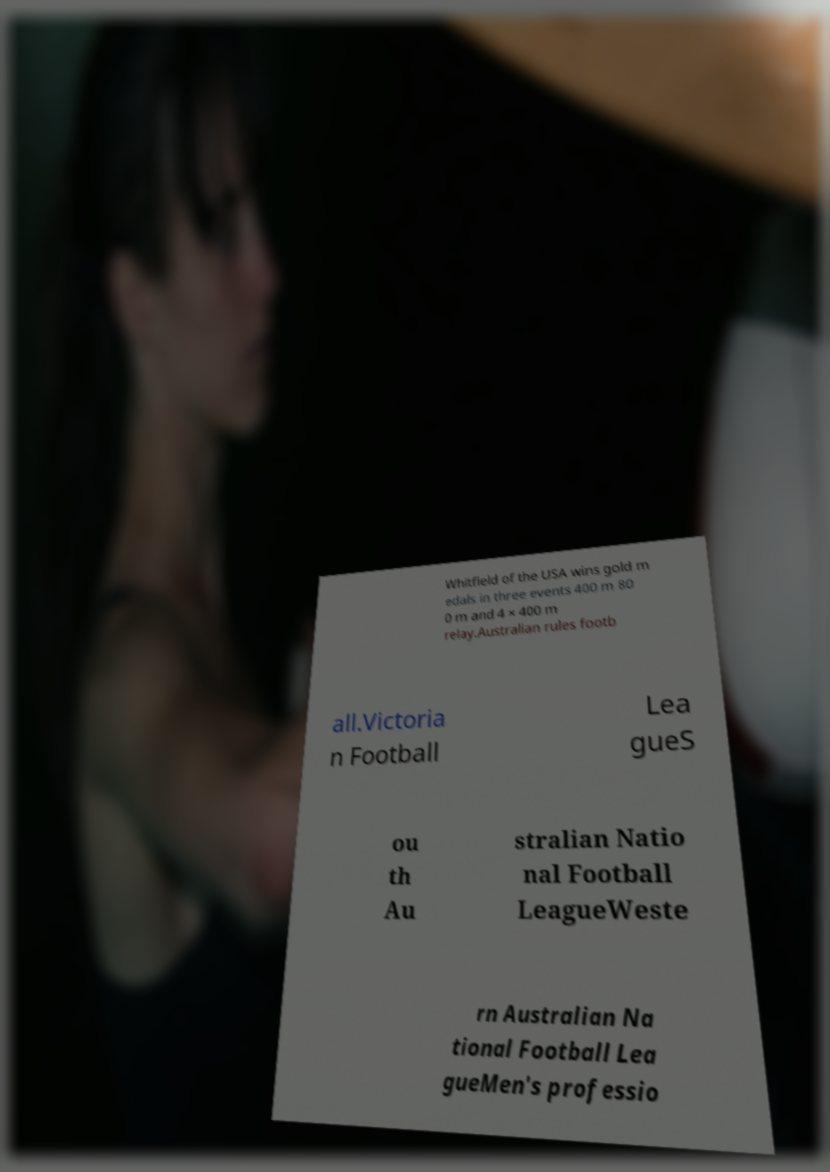Can you accurately transcribe the text from the provided image for me? Whitfield of the USA wins gold m edals in three events 400 m 80 0 m and 4 × 400 m relay.Australian rules footb all.Victoria n Football Lea gueS ou th Au stralian Natio nal Football LeagueWeste rn Australian Na tional Football Lea gueMen's professio 